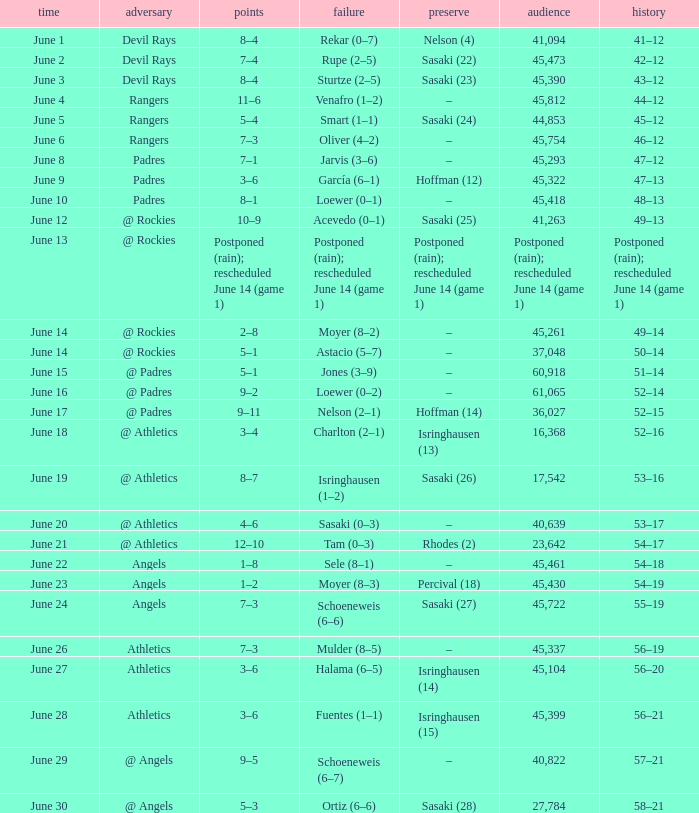What was the attendance of the Mariners game when they had a record of 56–20? 45104.0. 